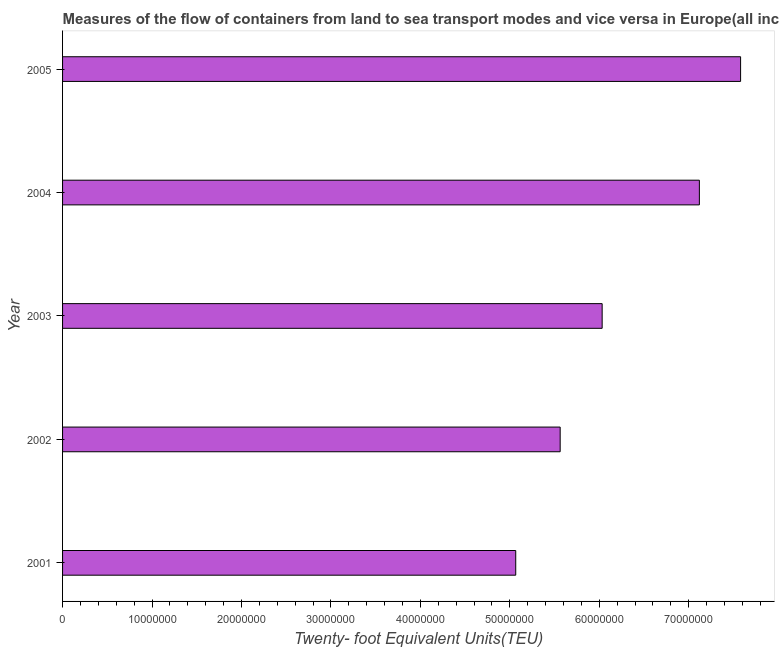Does the graph contain any zero values?
Your response must be concise. No. What is the title of the graph?
Your answer should be compact. Measures of the flow of containers from land to sea transport modes and vice versa in Europe(all income levels). What is the label or title of the X-axis?
Offer a very short reply. Twenty- foot Equivalent Units(TEU). What is the container port traffic in 2004?
Offer a terse response. 7.12e+07. Across all years, what is the maximum container port traffic?
Provide a short and direct response. 7.58e+07. Across all years, what is the minimum container port traffic?
Offer a very short reply. 5.07e+07. In which year was the container port traffic maximum?
Your answer should be compact. 2005. In which year was the container port traffic minimum?
Keep it short and to the point. 2001. What is the sum of the container port traffic?
Ensure brevity in your answer.  3.14e+08. What is the difference between the container port traffic in 2001 and 2003?
Make the answer very short. -9.66e+06. What is the average container port traffic per year?
Your answer should be compact. 6.27e+07. What is the median container port traffic?
Provide a succinct answer. 6.03e+07. In how many years, is the container port traffic greater than 38000000 TEU?
Keep it short and to the point. 5. Do a majority of the years between 2002 and 2005 (inclusive) have container port traffic greater than 20000000 TEU?
Provide a succinct answer. Yes. What is the ratio of the container port traffic in 2002 to that in 2004?
Your answer should be very brief. 0.78. What is the difference between the highest and the second highest container port traffic?
Offer a terse response. 4.61e+06. Is the sum of the container port traffic in 2003 and 2004 greater than the maximum container port traffic across all years?
Ensure brevity in your answer.  Yes. What is the difference between the highest and the lowest container port traffic?
Your answer should be compact. 2.51e+07. In how many years, is the container port traffic greater than the average container port traffic taken over all years?
Make the answer very short. 2. Are all the bars in the graph horizontal?
Keep it short and to the point. Yes. Are the values on the major ticks of X-axis written in scientific E-notation?
Your answer should be compact. No. What is the Twenty- foot Equivalent Units(TEU) in 2001?
Make the answer very short. 5.07e+07. What is the Twenty- foot Equivalent Units(TEU) of 2002?
Provide a short and direct response. 5.56e+07. What is the Twenty- foot Equivalent Units(TEU) in 2003?
Give a very brief answer. 6.03e+07. What is the Twenty- foot Equivalent Units(TEU) in 2004?
Provide a succinct answer. 7.12e+07. What is the Twenty- foot Equivalent Units(TEU) in 2005?
Make the answer very short. 7.58e+07. What is the difference between the Twenty- foot Equivalent Units(TEU) in 2001 and 2002?
Give a very brief answer. -4.97e+06. What is the difference between the Twenty- foot Equivalent Units(TEU) in 2001 and 2003?
Make the answer very short. -9.66e+06. What is the difference between the Twenty- foot Equivalent Units(TEU) in 2001 and 2004?
Your answer should be compact. -2.05e+07. What is the difference between the Twenty- foot Equivalent Units(TEU) in 2001 and 2005?
Provide a short and direct response. -2.51e+07. What is the difference between the Twenty- foot Equivalent Units(TEU) in 2002 and 2003?
Your response must be concise. -4.69e+06. What is the difference between the Twenty- foot Equivalent Units(TEU) in 2002 and 2004?
Your answer should be very brief. -1.56e+07. What is the difference between the Twenty- foot Equivalent Units(TEU) in 2002 and 2005?
Your answer should be compact. -2.02e+07. What is the difference between the Twenty- foot Equivalent Units(TEU) in 2003 and 2004?
Your response must be concise. -1.09e+07. What is the difference between the Twenty- foot Equivalent Units(TEU) in 2003 and 2005?
Provide a short and direct response. -1.55e+07. What is the difference between the Twenty- foot Equivalent Units(TEU) in 2004 and 2005?
Provide a short and direct response. -4.61e+06. What is the ratio of the Twenty- foot Equivalent Units(TEU) in 2001 to that in 2002?
Keep it short and to the point. 0.91. What is the ratio of the Twenty- foot Equivalent Units(TEU) in 2001 to that in 2003?
Offer a very short reply. 0.84. What is the ratio of the Twenty- foot Equivalent Units(TEU) in 2001 to that in 2004?
Your response must be concise. 0.71. What is the ratio of the Twenty- foot Equivalent Units(TEU) in 2001 to that in 2005?
Offer a very short reply. 0.67. What is the ratio of the Twenty- foot Equivalent Units(TEU) in 2002 to that in 2003?
Your response must be concise. 0.92. What is the ratio of the Twenty- foot Equivalent Units(TEU) in 2002 to that in 2004?
Offer a very short reply. 0.78. What is the ratio of the Twenty- foot Equivalent Units(TEU) in 2002 to that in 2005?
Offer a terse response. 0.73. What is the ratio of the Twenty- foot Equivalent Units(TEU) in 2003 to that in 2004?
Ensure brevity in your answer.  0.85. What is the ratio of the Twenty- foot Equivalent Units(TEU) in 2003 to that in 2005?
Your answer should be very brief. 0.8. What is the ratio of the Twenty- foot Equivalent Units(TEU) in 2004 to that in 2005?
Your answer should be compact. 0.94. 